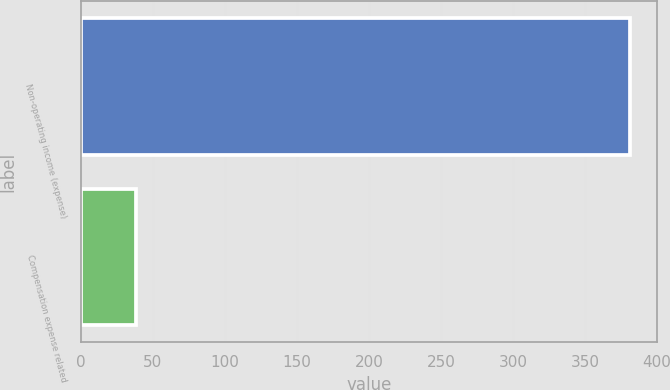<chart> <loc_0><loc_0><loc_500><loc_500><bar_chart><fcel>Non-operating income (expense)<fcel>Compensation expense related<nl><fcel>381<fcel>38<nl></chart> 